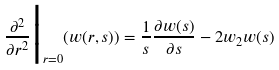Convert formula to latex. <formula><loc_0><loc_0><loc_500><loc_500>\frac { \partial ^ { 2 } } { \partial r ^ { 2 } } \Big | _ { r = 0 } ( w ( r , s ) ) = \frac { 1 } { s } \frac { \partial w ( s ) } { \partial s } - 2 w _ { 2 } w ( s )</formula> 